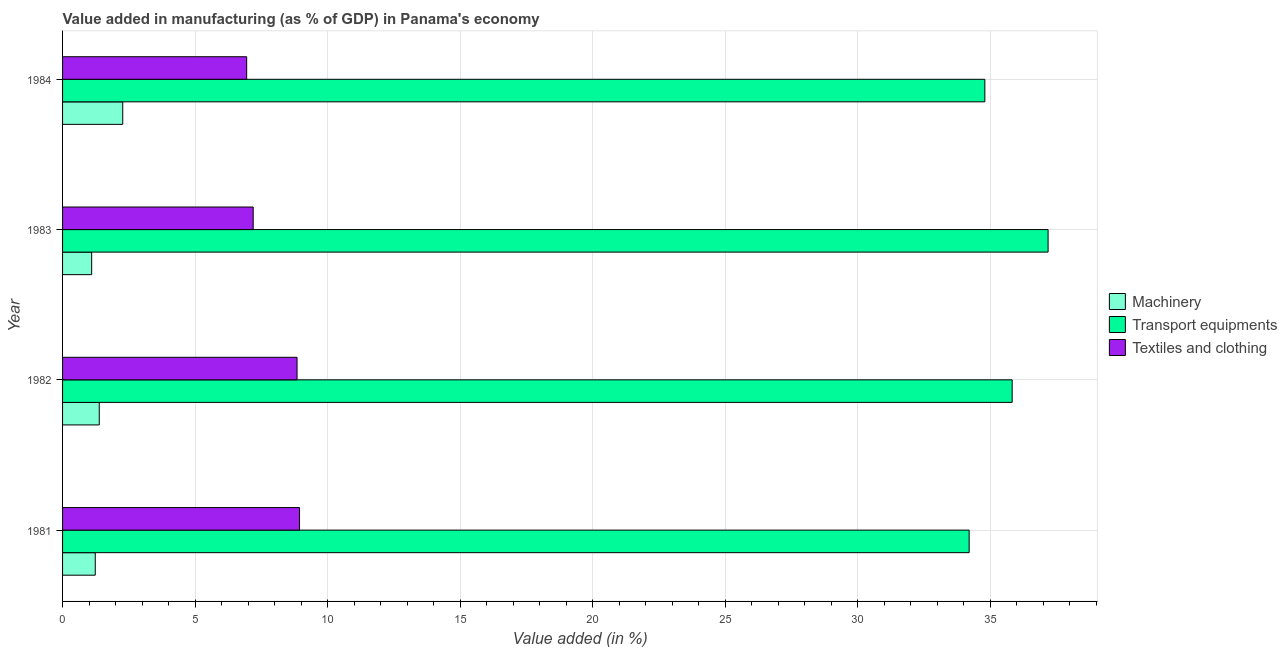How many groups of bars are there?
Make the answer very short. 4. Are the number of bars per tick equal to the number of legend labels?
Your response must be concise. Yes. How many bars are there on the 2nd tick from the top?
Your answer should be compact. 3. How many bars are there on the 2nd tick from the bottom?
Your answer should be compact. 3. What is the value added in manufacturing transport equipments in 1981?
Offer a terse response. 34.21. Across all years, what is the maximum value added in manufacturing machinery?
Offer a very short reply. 2.27. Across all years, what is the minimum value added in manufacturing machinery?
Keep it short and to the point. 1.1. In which year was the value added in manufacturing textile and clothing maximum?
Give a very brief answer. 1981. What is the total value added in manufacturing machinery in the graph?
Offer a terse response. 5.99. What is the difference between the value added in manufacturing textile and clothing in 1982 and that in 1984?
Keep it short and to the point. 1.9. What is the difference between the value added in manufacturing textile and clothing in 1984 and the value added in manufacturing transport equipments in 1982?
Your response must be concise. -28.89. What is the average value added in manufacturing transport equipments per year?
Give a very brief answer. 35.51. In the year 1982, what is the difference between the value added in manufacturing textile and clothing and value added in manufacturing transport equipments?
Give a very brief answer. -26.99. What is the ratio of the value added in manufacturing transport equipments in 1981 to that in 1983?
Provide a succinct answer. 0.92. Is the difference between the value added in manufacturing machinery in 1981 and 1982 greater than the difference between the value added in manufacturing transport equipments in 1981 and 1982?
Ensure brevity in your answer.  Yes. What is the difference between the highest and the second highest value added in manufacturing transport equipments?
Make the answer very short. 1.35. Is the sum of the value added in manufacturing textile and clothing in 1983 and 1984 greater than the maximum value added in manufacturing machinery across all years?
Your answer should be very brief. Yes. What does the 1st bar from the top in 1983 represents?
Your response must be concise. Textiles and clothing. What does the 2nd bar from the bottom in 1983 represents?
Provide a succinct answer. Transport equipments. How many bars are there?
Your answer should be very brief. 12. Are the values on the major ticks of X-axis written in scientific E-notation?
Your answer should be compact. No. Does the graph contain grids?
Ensure brevity in your answer.  Yes. How are the legend labels stacked?
Give a very brief answer. Vertical. What is the title of the graph?
Your answer should be compact. Value added in manufacturing (as % of GDP) in Panama's economy. Does "Oil sources" appear as one of the legend labels in the graph?
Keep it short and to the point. No. What is the label or title of the X-axis?
Keep it short and to the point. Value added (in %). What is the Value added (in %) in Machinery in 1981?
Give a very brief answer. 1.23. What is the Value added (in %) of Transport equipments in 1981?
Your answer should be very brief. 34.21. What is the Value added (in %) of Textiles and clothing in 1981?
Keep it short and to the point. 8.94. What is the Value added (in %) of Machinery in 1982?
Offer a terse response. 1.38. What is the Value added (in %) of Transport equipments in 1982?
Your response must be concise. 35.83. What is the Value added (in %) of Textiles and clothing in 1982?
Your answer should be very brief. 8.85. What is the Value added (in %) of Machinery in 1983?
Offer a terse response. 1.1. What is the Value added (in %) of Transport equipments in 1983?
Offer a terse response. 37.19. What is the Value added (in %) in Textiles and clothing in 1983?
Your response must be concise. 7.19. What is the Value added (in %) of Machinery in 1984?
Make the answer very short. 2.27. What is the Value added (in %) of Transport equipments in 1984?
Provide a succinct answer. 34.8. What is the Value added (in %) in Textiles and clothing in 1984?
Provide a short and direct response. 6.95. Across all years, what is the maximum Value added (in %) of Machinery?
Give a very brief answer. 2.27. Across all years, what is the maximum Value added (in %) in Transport equipments?
Provide a succinct answer. 37.19. Across all years, what is the maximum Value added (in %) of Textiles and clothing?
Keep it short and to the point. 8.94. Across all years, what is the minimum Value added (in %) in Machinery?
Offer a very short reply. 1.1. Across all years, what is the minimum Value added (in %) in Transport equipments?
Your answer should be compact. 34.21. Across all years, what is the minimum Value added (in %) in Textiles and clothing?
Offer a terse response. 6.95. What is the total Value added (in %) in Machinery in the graph?
Offer a very short reply. 5.99. What is the total Value added (in %) of Transport equipments in the graph?
Your answer should be very brief. 142.04. What is the total Value added (in %) in Textiles and clothing in the graph?
Offer a very short reply. 31.93. What is the difference between the Value added (in %) in Machinery in 1981 and that in 1982?
Your answer should be very brief. -0.15. What is the difference between the Value added (in %) of Transport equipments in 1981 and that in 1982?
Your answer should be compact. -1.62. What is the difference between the Value added (in %) of Textiles and clothing in 1981 and that in 1982?
Offer a very short reply. 0.09. What is the difference between the Value added (in %) in Machinery in 1981 and that in 1983?
Your answer should be very brief. 0.13. What is the difference between the Value added (in %) in Transport equipments in 1981 and that in 1983?
Give a very brief answer. -2.98. What is the difference between the Value added (in %) in Textiles and clothing in 1981 and that in 1983?
Ensure brevity in your answer.  1.75. What is the difference between the Value added (in %) in Machinery in 1981 and that in 1984?
Provide a short and direct response. -1.04. What is the difference between the Value added (in %) of Transport equipments in 1981 and that in 1984?
Your answer should be very brief. -0.59. What is the difference between the Value added (in %) of Textiles and clothing in 1981 and that in 1984?
Provide a short and direct response. 2. What is the difference between the Value added (in %) of Machinery in 1982 and that in 1983?
Your response must be concise. 0.29. What is the difference between the Value added (in %) in Transport equipments in 1982 and that in 1983?
Your response must be concise. -1.36. What is the difference between the Value added (in %) of Textiles and clothing in 1982 and that in 1983?
Your answer should be very brief. 1.65. What is the difference between the Value added (in %) of Machinery in 1982 and that in 1984?
Offer a terse response. -0.89. What is the difference between the Value added (in %) of Transport equipments in 1982 and that in 1984?
Offer a terse response. 1.03. What is the difference between the Value added (in %) of Textiles and clothing in 1982 and that in 1984?
Offer a very short reply. 1.9. What is the difference between the Value added (in %) in Machinery in 1983 and that in 1984?
Provide a succinct answer. -1.17. What is the difference between the Value added (in %) of Transport equipments in 1983 and that in 1984?
Keep it short and to the point. 2.39. What is the difference between the Value added (in %) in Textiles and clothing in 1983 and that in 1984?
Offer a very short reply. 0.25. What is the difference between the Value added (in %) in Machinery in 1981 and the Value added (in %) in Transport equipments in 1982?
Your response must be concise. -34.6. What is the difference between the Value added (in %) of Machinery in 1981 and the Value added (in %) of Textiles and clothing in 1982?
Your answer should be very brief. -7.62. What is the difference between the Value added (in %) in Transport equipments in 1981 and the Value added (in %) in Textiles and clothing in 1982?
Provide a short and direct response. 25.36. What is the difference between the Value added (in %) of Machinery in 1981 and the Value added (in %) of Transport equipments in 1983?
Provide a short and direct response. -35.96. What is the difference between the Value added (in %) of Machinery in 1981 and the Value added (in %) of Textiles and clothing in 1983?
Offer a terse response. -5.96. What is the difference between the Value added (in %) of Transport equipments in 1981 and the Value added (in %) of Textiles and clothing in 1983?
Offer a very short reply. 27.02. What is the difference between the Value added (in %) of Machinery in 1981 and the Value added (in %) of Transport equipments in 1984?
Keep it short and to the point. -33.57. What is the difference between the Value added (in %) in Machinery in 1981 and the Value added (in %) in Textiles and clothing in 1984?
Offer a terse response. -5.71. What is the difference between the Value added (in %) in Transport equipments in 1981 and the Value added (in %) in Textiles and clothing in 1984?
Your response must be concise. 27.26. What is the difference between the Value added (in %) of Machinery in 1982 and the Value added (in %) of Transport equipments in 1983?
Your answer should be very brief. -35.81. What is the difference between the Value added (in %) of Machinery in 1982 and the Value added (in %) of Textiles and clothing in 1983?
Keep it short and to the point. -5.81. What is the difference between the Value added (in %) of Transport equipments in 1982 and the Value added (in %) of Textiles and clothing in 1983?
Provide a succinct answer. 28.64. What is the difference between the Value added (in %) in Machinery in 1982 and the Value added (in %) in Transport equipments in 1984?
Keep it short and to the point. -33.42. What is the difference between the Value added (in %) of Machinery in 1982 and the Value added (in %) of Textiles and clothing in 1984?
Your answer should be compact. -5.56. What is the difference between the Value added (in %) in Transport equipments in 1982 and the Value added (in %) in Textiles and clothing in 1984?
Your answer should be very brief. 28.89. What is the difference between the Value added (in %) in Machinery in 1983 and the Value added (in %) in Transport equipments in 1984?
Offer a terse response. -33.7. What is the difference between the Value added (in %) in Machinery in 1983 and the Value added (in %) in Textiles and clothing in 1984?
Offer a very short reply. -5.85. What is the difference between the Value added (in %) of Transport equipments in 1983 and the Value added (in %) of Textiles and clothing in 1984?
Provide a short and direct response. 30.24. What is the average Value added (in %) of Machinery per year?
Offer a very short reply. 1.5. What is the average Value added (in %) of Transport equipments per year?
Give a very brief answer. 35.51. What is the average Value added (in %) of Textiles and clothing per year?
Offer a terse response. 7.98. In the year 1981, what is the difference between the Value added (in %) in Machinery and Value added (in %) in Transport equipments?
Provide a short and direct response. -32.98. In the year 1981, what is the difference between the Value added (in %) in Machinery and Value added (in %) in Textiles and clothing?
Your answer should be very brief. -7.71. In the year 1981, what is the difference between the Value added (in %) of Transport equipments and Value added (in %) of Textiles and clothing?
Give a very brief answer. 25.27. In the year 1982, what is the difference between the Value added (in %) of Machinery and Value added (in %) of Transport equipments?
Provide a short and direct response. -34.45. In the year 1982, what is the difference between the Value added (in %) in Machinery and Value added (in %) in Textiles and clothing?
Give a very brief answer. -7.46. In the year 1982, what is the difference between the Value added (in %) of Transport equipments and Value added (in %) of Textiles and clothing?
Offer a terse response. 26.99. In the year 1983, what is the difference between the Value added (in %) in Machinery and Value added (in %) in Transport equipments?
Your answer should be very brief. -36.09. In the year 1983, what is the difference between the Value added (in %) in Machinery and Value added (in %) in Textiles and clothing?
Keep it short and to the point. -6.09. In the year 1983, what is the difference between the Value added (in %) in Transport equipments and Value added (in %) in Textiles and clothing?
Offer a terse response. 30. In the year 1984, what is the difference between the Value added (in %) of Machinery and Value added (in %) of Transport equipments?
Keep it short and to the point. -32.53. In the year 1984, what is the difference between the Value added (in %) of Machinery and Value added (in %) of Textiles and clothing?
Keep it short and to the point. -4.68. In the year 1984, what is the difference between the Value added (in %) of Transport equipments and Value added (in %) of Textiles and clothing?
Give a very brief answer. 27.86. What is the ratio of the Value added (in %) of Machinery in 1981 to that in 1982?
Offer a very short reply. 0.89. What is the ratio of the Value added (in %) of Transport equipments in 1981 to that in 1982?
Make the answer very short. 0.95. What is the ratio of the Value added (in %) in Textiles and clothing in 1981 to that in 1982?
Give a very brief answer. 1.01. What is the ratio of the Value added (in %) in Machinery in 1981 to that in 1983?
Your answer should be compact. 1.12. What is the ratio of the Value added (in %) of Transport equipments in 1981 to that in 1983?
Ensure brevity in your answer.  0.92. What is the ratio of the Value added (in %) in Textiles and clothing in 1981 to that in 1983?
Give a very brief answer. 1.24. What is the ratio of the Value added (in %) in Machinery in 1981 to that in 1984?
Give a very brief answer. 0.54. What is the ratio of the Value added (in %) of Transport equipments in 1981 to that in 1984?
Ensure brevity in your answer.  0.98. What is the ratio of the Value added (in %) of Textiles and clothing in 1981 to that in 1984?
Provide a short and direct response. 1.29. What is the ratio of the Value added (in %) of Machinery in 1982 to that in 1983?
Your answer should be very brief. 1.26. What is the ratio of the Value added (in %) of Transport equipments in 1982 to that in 1983?
Your answer should be very brief. 0.96. What is the ratio of the Value added (in %) in Textiles and clothing in 1982 to that in 1983?
Ensure brevity in your answer.  1.23. What is the ratio of the Value added (in %) in Machinery in 1982 to that in 1984?
Offer a terse response. 0.61. What is the ratio of the Value added (in %) of Transport equipments in 1982 to that in 1984?
Keep it short and to the point. 1.03. What is the ratio of the Value added (in %) in Textiles and clothing in 1982 to that in 1984?
Keep it short and to the point. 1.27. What is the ratio of the Value added (in %) of Machinery in 1983 to that in 1984?
Give a very brief answer. 0.48. What is the ratio of the Value added (in %) in Transport equipments in 1983 to that in 1984?
Make the answer very short. 1.07. What is the ratio of the Value added (in %) in Textiles and clothing in 1983 to that in 1984?
Ensure brevity in your answer.  1.04. What is the difference between the highest and the second highest Value added (in %) in Machinery?
Ensure brevity in your answer.  0.89. What is the difference between the highest and the second highest Value added (in %) of Transport equipments?
Give a very brief answer. 1.36. What is the difference between the highest and the second highest Value added (in %) of Textiles and clothing?
Provide a short and direct response. 0.09. What is the difference between the highest and the lowest Value added (in %) of Machinery?
Your answer should be compact. 1.17. What is the difference between the highest and the lowest Value added (in %) of Transport equipments?
Make the answer very short. 2.98. What is the difference between the highest and the lowest Value added (in %) in Textiles and clothing?
Ensure brevity in your answer.  2. 